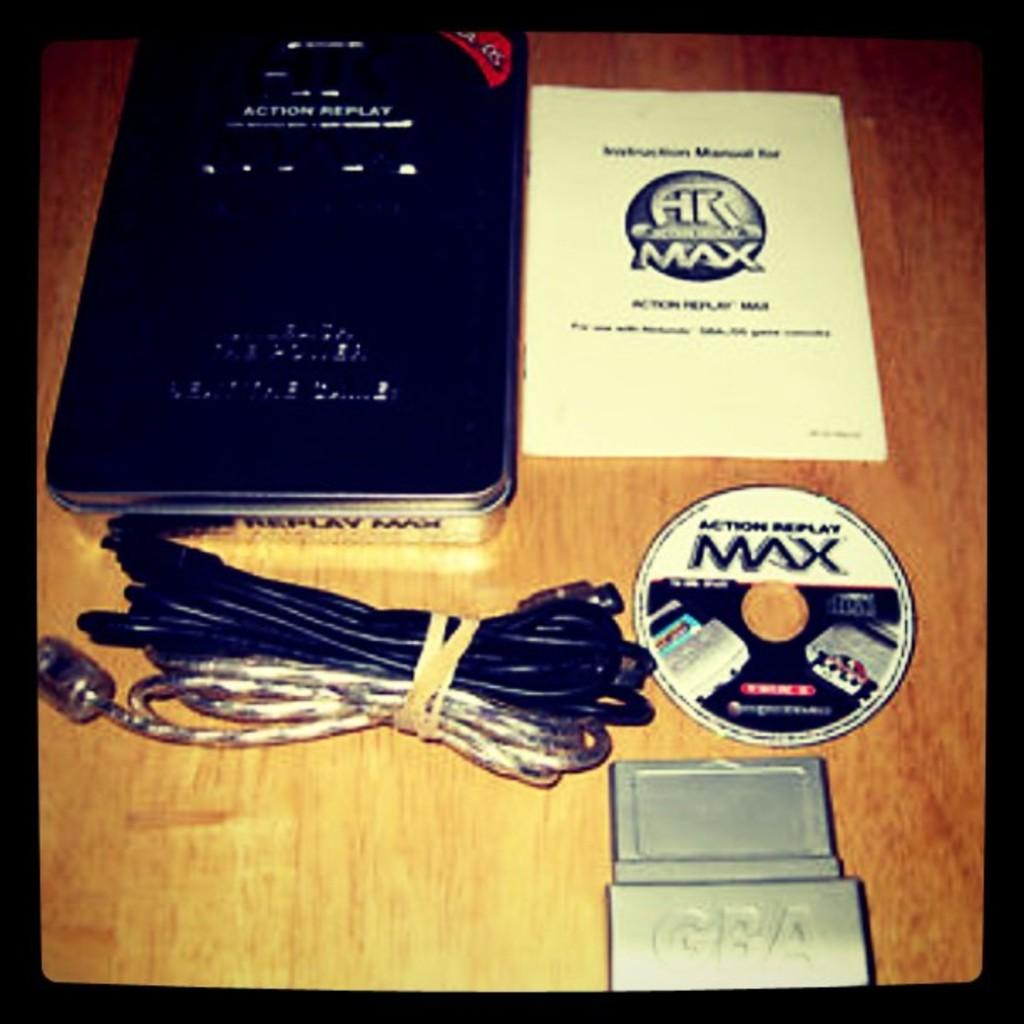<image>
Present a compact description of the photo's key features. A pile of electronic things having to do with a game called Action Replay Max. 